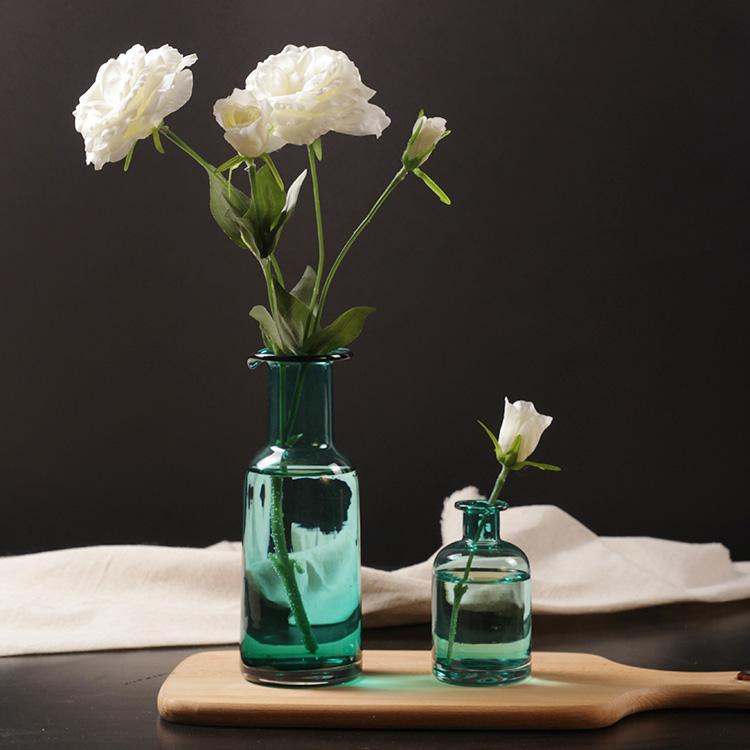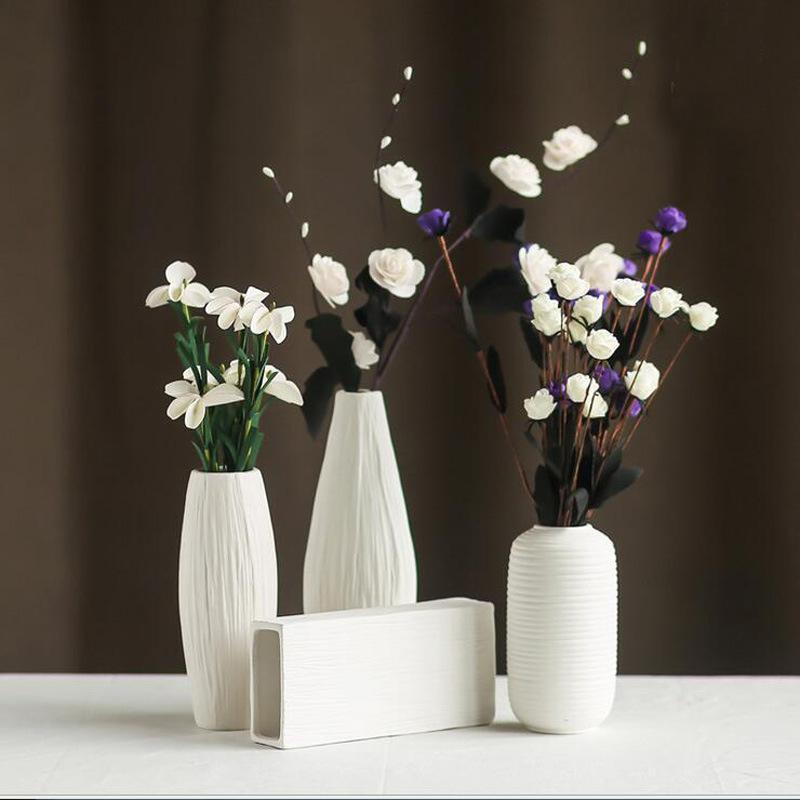The first image is the image on the left, the second image is the image on the right. Analyze the images presented: Is the assertion "There are three white vases with flowers in the image on the right." valid? Answer yes or no. Yes. 